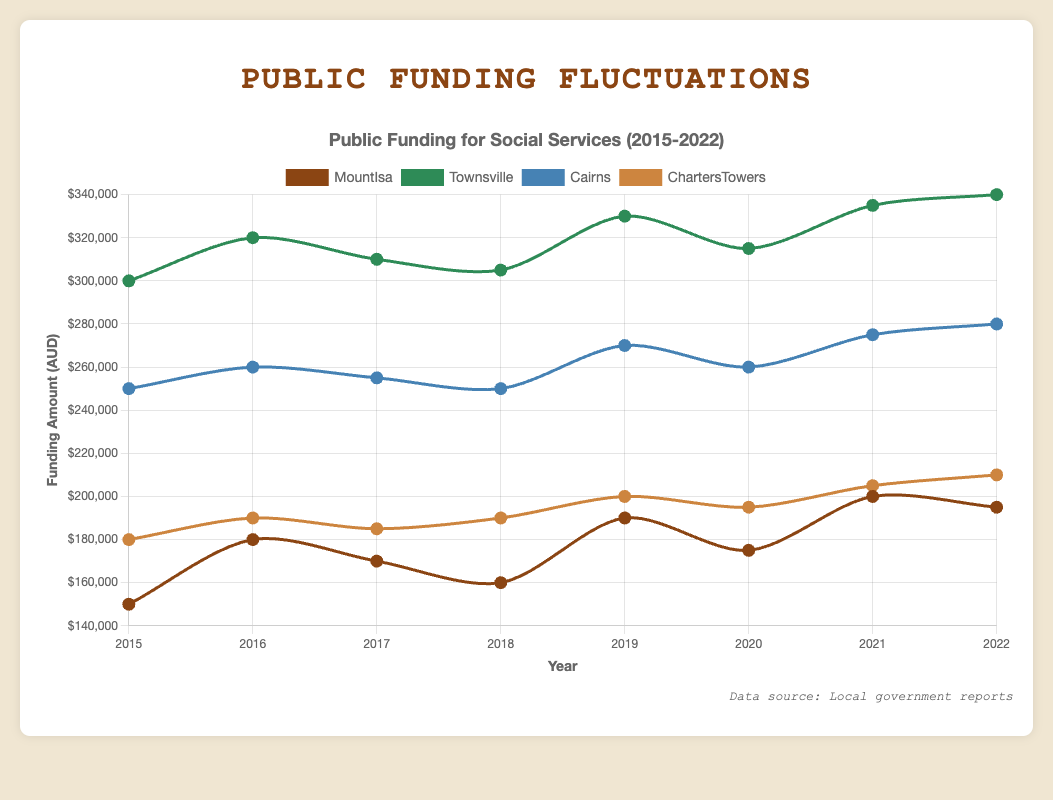What year did Mount Isa experience the highest funding amount? By looking at the chart, observe the peaks for the Mount Isa line. The highest point is in the year 2021.
Answer: 2021 Which region had the highest increase in public funding from 2015 to 2022? Calculate the difference between 2022 and 2015 for each region. Townsville increased from 300,000 to 340,000, gaining 40,000; Cairns increased from 250,000 to 280,000, gaining 30,000; Charters Towers from 180,000 to 210,000, gaining 30,000; Mount Isa from 150,000 to 195,000, gaining 45,000. Mount Isa has the highest increase.
Answer: Mount Isa Between which consecutive years did Townsville experience its largest funding decrease? Look at the dips in the Townsville line in the chart. The largest drop is between 2019 and 2020, from 330,000 to 315,000, a decrease by 15,000.
Answer: 2019 to 2020 How many years did Cairns stay constant at 250,000 in public funding? Check for periods where the Cairns line does not change. This happens between 2017 and 2018, and possibly partially for another year. Count the years Cairns was steady.
Answer: 1 year In which year were funding amounts for Charters Towers and Cairns equal? Compare the points on Charters Towers and Cairns lines to find where they intersect or are the same height. In 2016, both were at 190,000.
Answer: 2016 What is the average funding amount for Mount Isa over the 8 years? Sum the values for Mount Isa over 2015-2022 and divide by 8: (150,000 + 180,000 + 170,000 + 160,000 + 190,000 + 175,000 + 200,000 + 195,000) = 1,420,000. Then divide by 8.
Answer: 177,500 Which region had the most stable (least fluctuating) funding over the years? Look at the variability of each line. Townsville, Cairns, and Charters Towers show less fluctuation compared to Mount Isa's varied changes. Cairns seems the most stable: it ranges from 250,000 to 280,000.
Answer: Cairns 